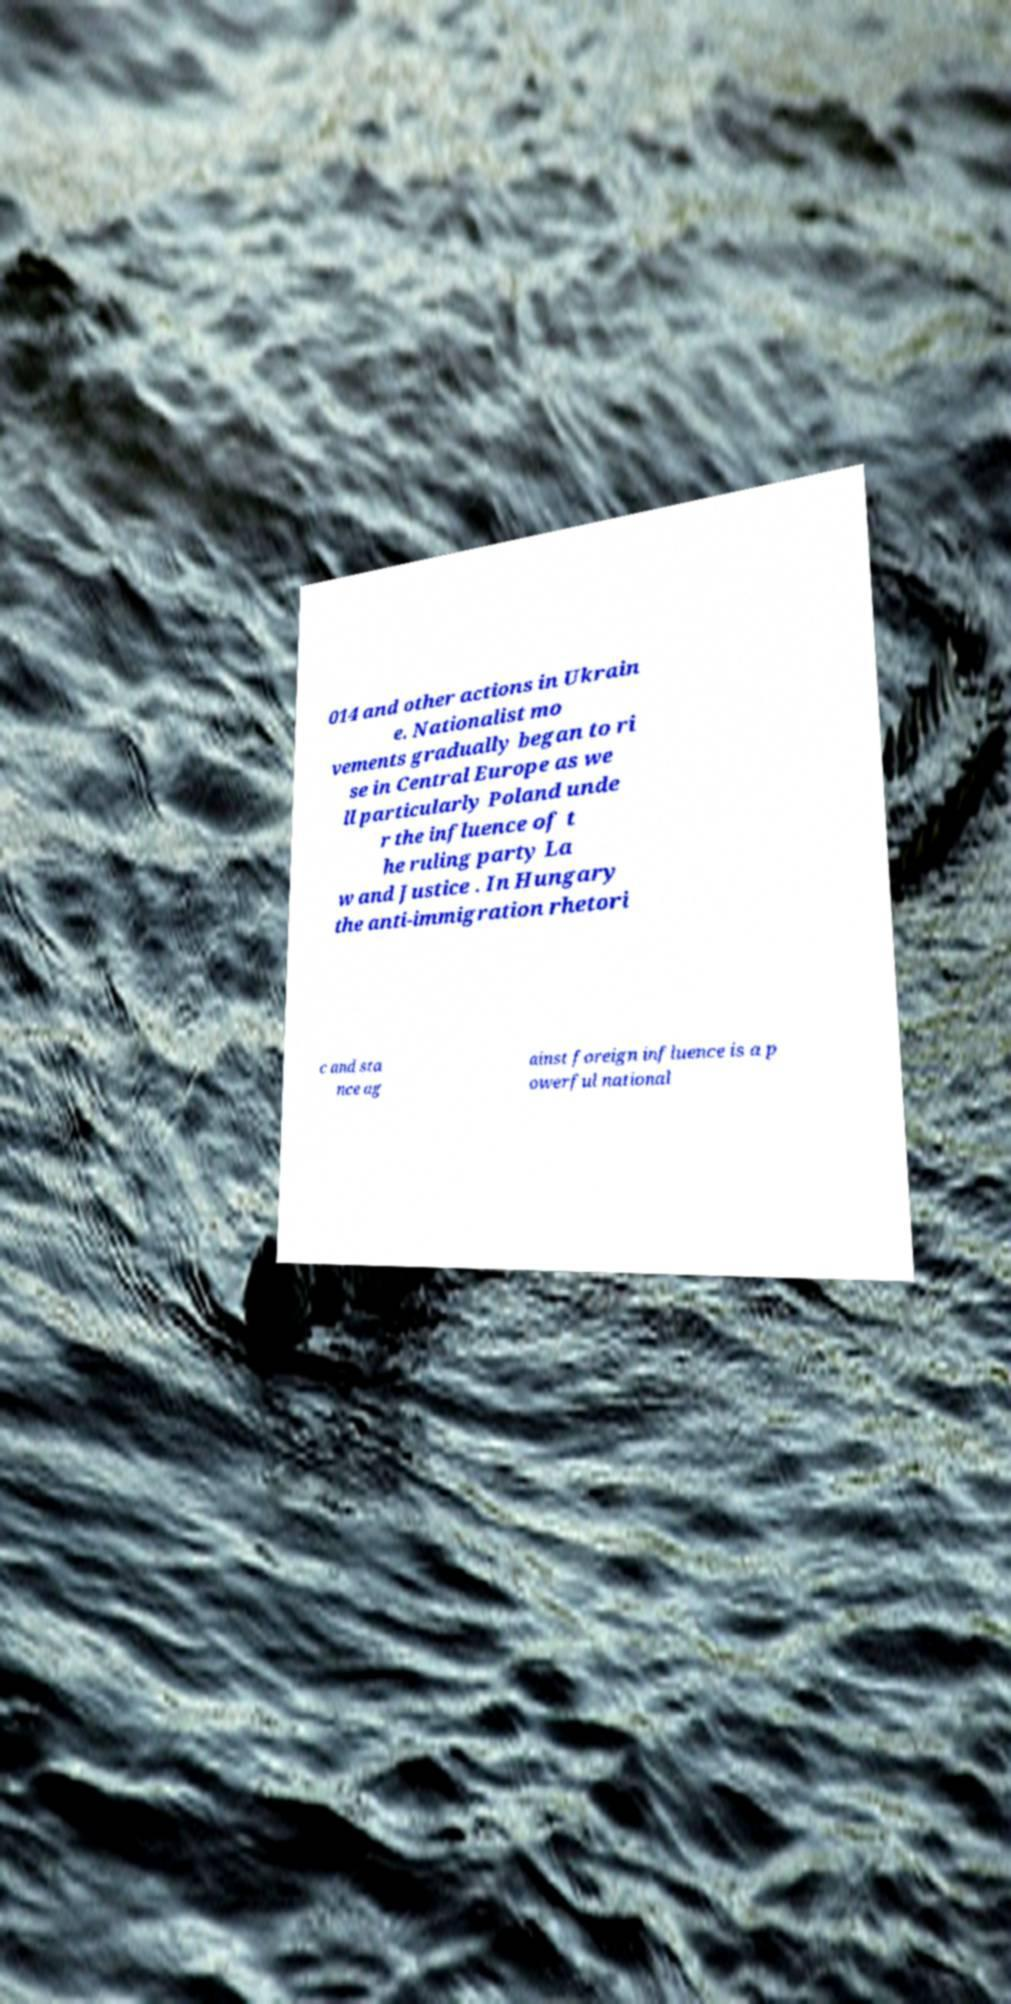Can you accurately transcribe the text from the provided image for me? 014 and other actions in Ukrain e. Nationalist mo vements gradually began to ri se in Central Europe as we ll particularly Poland unde r the influence of t he ruling party La w and Justice . In Hungary the anti-immigration rhetori c and sta nce ag ainst foreign influence is a p owerful national 